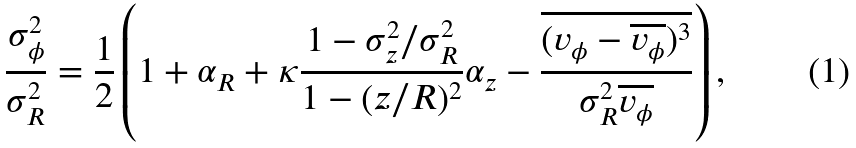<formula> <loc_0><loc_0><loc_500><loc_500>\frac { \sigma _ { \phi } ^ { 2 } } { \sigma _ { R } ^ { 2 } } = \frac { 1 } { 2 } \left ( 1 + \alpha _ { R } + \kappa \frac { 1 - \sigma _ { z } ^ { 2 } / \sigma _ { R } ^ { 2 } } { 1 - ( z / R ) ^ { 2 } } \alpha _ { z } - \frac { \overline { ( v _ { \phi } - \overline { v _ { \phi } } ) ^ { 3 } } } { \sigma _ { R } ^ { 2 } \overline { v _ { \phi } } } \right ) ,</formula> 